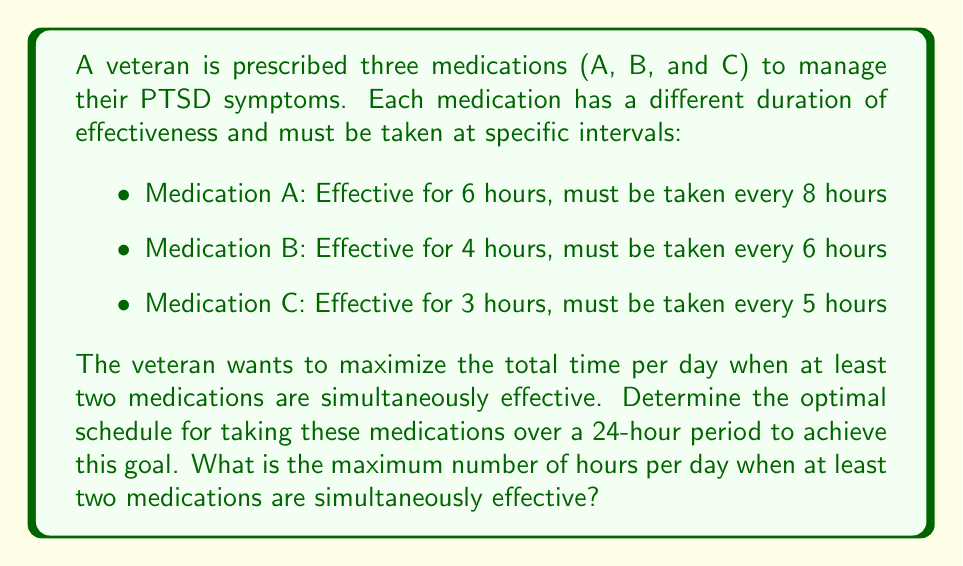What is the answer to this math problem? To solve this optimization problem, we need to follow these steps:

1) First, let's visualize the effectiveness cycles of each medication over 24 hours:

   A: |‾‾‾‾‾‾__||‾‾‾‾‾‾__||‾‾‾‾‾‾__|
   B: |‾‾‾‾__||‾‾‾‾__||‾‾‾‾__||‾‾‾‾__|
   C: |‾‾‾__||‾‾‾__||‾‾‾__||‾‾‾__||‾‾‾|

   Where ‾ represents effective periods and _ represents ineffective periods.

2) To maximize the overlap, we should align the start times of the effective periods. Let's set the start of the 24-hour period as the simultaneous start for all medications.

3) Now, we need to calculate the least common multiple (LCM) of the dosing intervals to determine the repeat cycle:

   LCM(8, 6, 5) = 120 hours

   This means the pattern will repeat every 120 hours, or 5 days.

4) Within this 120-hour cycle, we have:
   - 15 doses of Medication A (120 ÷ 8)
   - 20 doses of Medication B (120 ÷ 6)
   - 24 doses of Medication C (120 ÷ 5)

5) Now, let's calculate the total effective hours for each medication in 120 hours:
   - A: 15 * 6 = 90 hours
   - B: 20 * 4 = 80 hours
   - C: 24 * 3 = 72 hours

6) To find periods when at least two medications are effective, we can use the inclusion-exclusion principle:

   Let $T_2$ be the time when at least two medications are effective.
   Let $T_A$, $T_B$, and $T_C$ be the total effective times for each medication.
   Let $T_{AB}$, $T_{BC}$, and $T_{AC}$ be the times when each pair of medications overlap.
   Let $T_{ABC}$ be the time when all three medications overlap.

   $$T_2 = T_{AB} + T_{BC} + T_{AC} - 2T_{ABC}$$

7) Calculate the overlap times:
   $T_{AB} = 6$ (occurs every 24 hours, 5 times in 120 hours)
   $T_{BC} = 4$ (occurs every 30 hours, 4 times in 120 hours)
   $T_{AC} = 3$ (occurs every 40 hours, 3 times in 120 hours)
   $T_{ABC} = 3$ (occurs once every 120 hours)

8) Substituting into the formula:
   $$T_2 = (6 * 5) + (4 * 4) + (3 * 3) - (2 * 3) = 30 + 16 + 9 - 6 = 49$$

9) Therefore, in a 120-hour cycle, there are 49 hours where at least two medications are simultaneously effective.

10) To convert this to a 24-hour period, we divide by 5:
    $$49 \div 5 = 9.8$$

Thus, the maximum number of hours per day when at least two medications are simultaneously effective is 9.8 hours.
Answer: 9.8 hours 